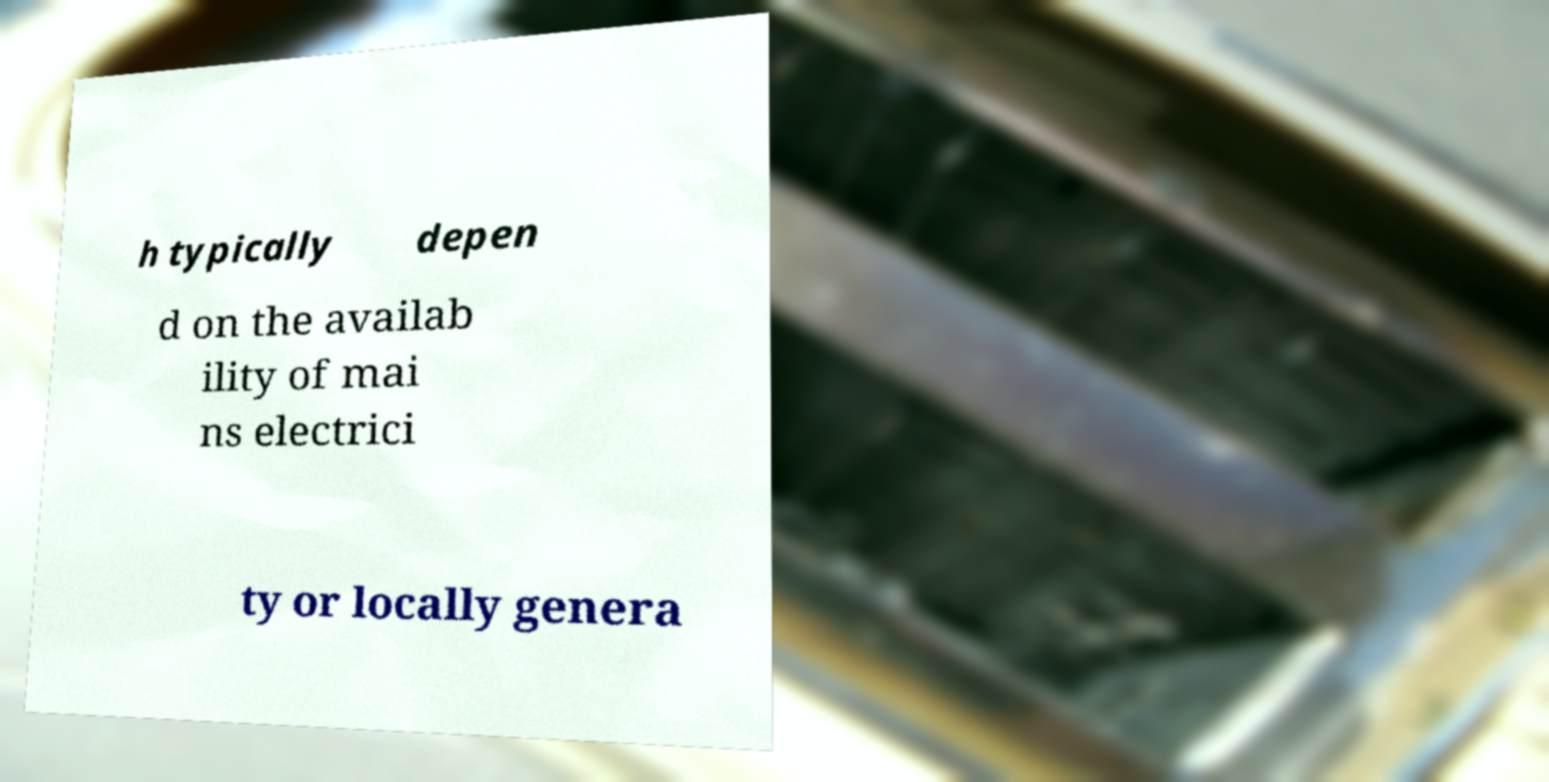Can you read and provide the text displayed in the image?This photo seems to have some interesting text. Can you extract and type it out for me? h typically depen d on the availab ility of mai ns electrici ty or locally genera 